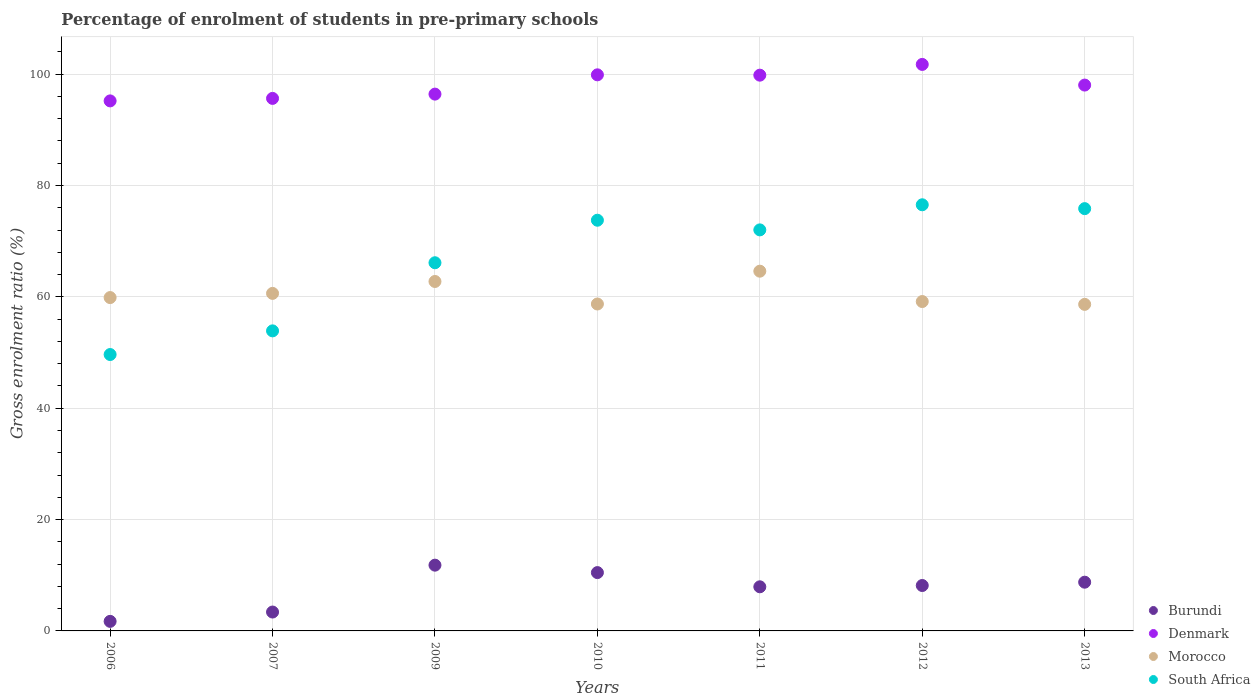Is the number of dotlines equal to the number of legend labels?
Your response must be concise. Yes. What is the percentage of students enrolled in pre-primary schools in Denmark in 2012?
Your answer should be compact. 101.75. Across all years, what is the maximum percentage of students enrolled in pre-primary schools in South Africa?
Make the answer very short. 76.54. Across all years, what is the minimum percentage of students enrolled in pre-primary schools in Morocco?
Provide a short and direct response. 58.66. In which year was the percentage of students enrolled in pre-primary schools in Burundi maximum?
Your answer should be compact. 2009. What is the total percentage of students enrolled in pre-primary schools in South Africa in the graph?
Offer a terse response. 467.86. What is the difference between the percentage of students enrolled in pre-primary schools in Burundi in 2006 and that in 2009?
Offer a terse response. -10.1. What is the difference between the percentage of students enrolled in pre-primary schools in Burundi in 2011 and the percentage of students enrolled in pre-primary schools in South Africa in 2010?
Your response must be concise. -65.84. What is the average percentage of students enrolled in pre-primary schools in South Africa per year?
Provide a short and direct response. 66.84. In the year 2006, what is the difference between the percentage of students enrolled in pre-primary schools in South Africa and percentage of students enrolled in pre-primary schools in Denmark?
Your answer should be very brief. -45.56. What is the ratio of the percentage of students enrolled in pre-primary schools in Denmark in 2007 to that in 2013?
Make the answer very short. 0.98. What is the difference between the highest and the second highest percentage of students enrolled in pre-primary schools in Denmark?
Provide a succinct answer. 1.87. What is the difference between the highest and the lowest percentage of students enrolled in pre-primary schools in South Africa?
Provide a short and direct response. 26.9. In how many years, is the percentage of students enrolled in pre-primary schools in Morocco greater than the average percentage of students enrolled in pre-primary schools in Morocco taken over all years?
Offer a terse response. 2. Is it the case that in every year, the sum of the percentage of students enrolled in pre-primary schools in Denmark and percentage of students enrolled in pre-primary schools in Burundi  is greater than the sum of percentage of students enrolled in pre-primary schools in Morocco and percentage of students enrolled in pre-primary schools in South Africa?
Keep it short and to the point. No. Is it the case that in every year, the sum of the percentage of students enrolled in pre-primary schools in Burundi and percentage of students enrolled in pre-primary schools in Denmark  is greater than the percentage of students enrolled in pre-primary schools in Morocco?
Provide a short and direct response. Yes. Does the percentage of students enrolled in pre-primary schools in Morocco monotonically increase over the years?
Your answer should be compact. No. How many dotlines are there?
Ensure brevity in your answer.  4. What is the difference between two consecutive major ticks on the Y-axis?
Give a very brief answer. 20. Does the graph contain any zero values?
Give a very brief answer. No. How many legend labels are there?
Offer a very short reply. 4. What is the title of the graph?
Give a very brief answer. Percentage of enrolment of students in pre-primary schools. Does "Guam" appear as one of the legend labels in the graph?
Offer a very short reply. No. What is the label or title of the X-axis?
Your response must be concise. Years. What is the Gross enrolment ratio (%) of Burundi in 2006?
Ensure brevity in your answer.  1.72. What is the Gross enrolment ratio (%) in Denmark in 2006?
Make the answer very short. 95.2. What is the Gross enrolment ratio (%) in Morocco in 2006?
Your response must be concise. 59.88. What is the Gross enrolment ratio (%) of South Africa in 2006?
Make the answer very short. 49.65. What is the Gross enrolment ratio (%) in Burundi in 2007?
Ensure brevity in your answer.  3.39. What is the Gross enrolment ratio (%) in Denmark in 2007?
Your answer should be very brief. 95.65. What is the Gross enrolment ratio (%) in Morocco in 2007?
Provide a succinct answer. 60.63. What is the Gross enrolment ratio (%) in South Africa in 2007?
Your answer should be compact. 53.89. What is the Gross enrolment ratio (%) of Burundi in 2009?
Ensure brevity in your answer.  11.81. What is the Gross enrolment ratio (%) in Denmark in 2009?
Your response must be concise. 96.42. What is the Gross enrolment ratio (%) of Morocco in 2009?
Provide a succinct answer. 62.77. What is the Gross enrolment ratio (%) of South Africa in 2009?
Offer a terse response. 66.13. What is the Gross enrolment ratio (%) of Burundi in 2010?
Provide a succinct answer. 10.48. What is the Gross enrolment ratio (%) of Denmark in 2010?
Give a very brief answer. 99.88. What is the Gross enrolment ratio (%) of Morocco in 2010?
Offer a very short reply. 58.72. What is the Gross enrolment ratio (%) in South Africa in 2010?
Provide a short and direct response. 73.77. What is the Gross enrolment ratio (%) of Burundi in 2011?
Provide a short and direct response. 7.93. What is the Gross enrolment ratio (%) of Denmark in 2011?
Keep it short and to the point. 99.82. What is the Gross enrolment ratio (%) in Morocco in 2011?
Give a very brief answer. 64.61. What is the Gross enrolment ratio (%) in South Africa in 2011?
Provide a short and direct response. 72.03. What is the Gross enrolment ratio (%) of Burundi in 2012?
Keep it short and to the point. 8.16. What is the Gross enrolment ratio (%) of Denmark in 2012?
Your answer should be very brief. 101.75. What is the Gross enrolment ratio (%) in Morocco in 2012?
Make the answer very short. 59.16. What is the Gross enrolment ratio (%) in South Africa in 2012?
Provide a short and direct response. 76.54. What is the Gross enrolment ratio (%) of Burundi in 2013?
Offer a terse response. 8.75. What is the Gross enrolment ratio (%) in Denmark in 2013?
Offer a terse response. 98.04. What is the Gross enrolment ratio (%) in Morocco in 2013?
Your response must be concise. 58.66. What is the Gross enrolment ratio (%) in South Africa in 2013?
Ensure brevity in your answer.  75.85. Across all years, what is the maximum Gross enrolment ratio (%) in Burundi?
Make the answer very short. 11.81. Across all years, what is the maximum Gross enrolment ratio (%) of Denmark?
Keep it short and to the point. 101.75. Across all years, what is the maximum Gross enrolment ratio (%) of Morocco?
Provide a succinct answer. 64.61. Across all years, what is the maximum Gross enrolment ratio (%) in South Africa?
Make the answer very short. 76.54. Across all years, what is the minimum Gross enrolment ratio (%) in Burundi?
Your response must be concise. 1.72. Across all years, what is the minimum Gross enrolment ratio (%) of Denmark?
Offer a very short reply. 95.2. Across all years, what is the minimum Gross enrolment ratio (%) in Morocco?
Offer a terse response. 58.66. Across all years, what is the minimum Gross enrolment ratio (%) of South Africa?
Keep it short and to the point. 49.65. What is the total Gross enrolment ratio (%) in Burundi in the graph?
Keep it short and to the point. 52.23. What is the total Gross enrolment ratio (%) of Denmark in the graph?
Offer a terse response. 686.78. What is the total Gross enrolment ratio (%) in Morocco in the graph?
Provide a short and direct response. 424.42. What is the total Gross enrolment ratio (%) of South Africa in the graph?
Keep it short and to the point. 467.86. What is the difference between the Gross enrolment ratio (%) in Burundi in 2006 and that in 2007?
Offer a terse response. -1.68. What is the difference between the Gross enrolment ratio (%) of Denmark in 2006 and that in 2007?
Provide a succinct answer. -0.45. What is the difference between the Gross enrolment ratio (%) of Morocco in 2006 and that in 2007?
Make the answer very short. -0.75. What is the difference between the Gross enrolment ratio (%) of South Africa in 2006 and that in 2007?
Provide a succinct answer. -4.25. What is the difference between the Gross enrolment ratio (%) in Burundi in 2006 and that in 2009?
Offer a very short reply. -10.1. What is the difference between the Gross enrolment ratio (%) in Denmark in 2006 and that in 2009?
Make the answer very short. -1.22. What is the difference between the Gross enrolment ratio (%) in Morocco in 2006 and that in 2009?
Your response must be concise. -2.89. What is the difference between the Gross enrolment ratio (%) of South Africa in 2006 and that in 2009?
Your response must be concise. -16.49. What is the difference between the Gross enrolment ratio (%) of Burundi in 2006 and that in 2010?
Provide a short and direct response. -8.76. What is the difference between the Gross enrolment ratio (%) in Denmark in 2006 and that in 2010?
Make the answer very short. -4.68. What is the difference between the Gross enrolment ratio (%) in Morocco in 2006 and that in 2010?
Keep it short and to the point. 1.15. What is the difference between the Gross enrolment ratio (%) of South Africa in 2006 and that in 2010?
Make the answer very short. -24.12. What is the difference between the Gross enrolment ratio (%) in Burundi in 2006 and that in 2011?
Ensure brevity in your answer.  -6.21. What is the difference between the Gross enrolment ratio (%) of Denmark in 2006 and that in 2011?
Your answer should be very brief. -4.62. What is the difference between the Gross enrolment ratio (%) of Morocco in 2006 and that in 2011?
Offer a very short reply. -4.74. What is the difference between the Gross enrolment ratio (%) in South Africa in 2006 and that in 2011?
Provide a short and direct response. -22.39. What is the difference between the Gross enrolment ratio (%) in Burundi in 2006 and that in 2012?
Your answer should be very brief. -6.44. What is the difference between the Gross enrolment ratio (%) of Denmark in 2006 and that in 2012?
Your response must be concise. -6.55. What is the difference between the Gross enrolment ratio (%) in Morocco in 2006 and that in 2012?
Ensure brevity in your answer.  0.71. What is the difference between the Gross enrolment ratio (%) in South Africa in 2006 and that in 2012?
Your answer should be compact. -26.9. What is the difference between the Gross enrolment ratio (%) in Burundi in 2006 and that in 2013?
Make the answer very short. -7.04. What is the difference between the Gross enrolment ratio (%) of Denmark in 2006 and that in 2013?
Make the answer very short. -2.84. What is the difference between the Gross enrolment ratio (%) of Morocco in 2006 and that in 2013?
Offer a terse response. 1.22. What is the difference between the Gross enrolment ratio (%) of South Africa in 2006 and that in 2013?
Provide a succinct answer. -26.2. What is the difference between the Gross enrolment ratio (%) in Burundi in 2007 and that in 2009?
Your answer should be very brief. -8.42. What is the difference between the Gross enrolment ratio (%) in Denmark in 2007 and that in 2009?
Provide a short and direct response. -0.77. What is the difference between the Gross enrolment ratio (%) of Morocco in 2007 and that in 2009?
Your response must be concise. -2.14. What is the difference between the Gross enrolment ratio (%) of South Africa in 2007 and that in 2009?
Give a very brief answer. -12.24. What is the difference between the Gross enrolment ratio (%) of Burundi in 2007 and that in 2010?
Your answer should be compact. -7.08. What is the difference between the Gross enrolment ratio (%) in Denmark in 2007 and that in 2010?
Your response must be concise. -4.23. What is the difference between the Gross enrolment ratio (%) in Morocco in 2007 and that in 2010?
Ensure brevity in your answer.  1.91. What is the difference between the Gross enrolment ratio (%) of South Africa in 2007 and that in 2010?
Keep it short and to the point. -19.87. What is the difference between the Gross enrolment ratio (%) of Burundi in 2007 and that in 2011?
Your answer should be very brief. -4.53. What is the difference between the Gross enrolment ratio (%) in Denmark in 2007 and that in 2011?
Provide a succinct answer. -4.17. What is the difference between the Gross enrolment ratio (%) of Morocco in 2007 and that in 2011?
Provide a succinct answer. -3.99. What is the difference between the Gross enrolment ratio (%) in South Africa in 2007 and that in 2011?
Your answer should be very brief. -18.14. What is the difference between the Gross enrolment ratio (%) in Burundi in 2007 and that in 2012?
Make the answer very short. -4.77. What is the difference between the Gross enrolment ratio (%) of Denmark in 2007 and that in 2012?
Your answer should be very brief. -6.1. What is the difference between the Gross enrolment ratio (%) of Morocco in 2007 and that in 2012?
Your response must be concise. 1.46. What is the difference between the Gross enrolment ratio (%) of South Africa in 2007 and that in 2012?
Your answer should be very brief. -22.65. What is the difference between the Gross enrolment ratio (%) in Burundi in 2007 and that in 2013?
Your answer should be compact. -5.36. What is the difference between the Gross enrolment ratio (%) in Denmark in 2007 and that in 2013?
Your response must be concise. -2.39. What is the difference between the Gross enrolment ratio (%) of Morocco in 2007 and that in 2013?
Give a very brief answer. 1.97. What is the difference between the Gross enrolment ratio (%) of South Africa in 2007 and that in 2013?
Ensure brevity in your answer.  -21.96. What is the difference between the Gross enrolment ratio (%) in Burundi in 2009 and that in 2010?
Give a very brief answer. 1.34. What is the difference between the Gross enrolment ratio (%) of Denmark in 2009 and that in 2010?
Make the answer very short. -3.47. What is the difference between the Gross enrolment ratio (%) of Morocco in 2009 and that in 2010?
Your answer should be very brief. 4.04. What is the difference between the Gross enrolment ratio (%) of South Africa in 2009 and that in 2010?
Your answer should be compact. -7.64. What is the difference between the Gross enrolment ratio (%) of Burundi in 2009 and that in 2011?
Keep it short and to the point. 3.89. What is the difference between the Gross enrolment ratio (%) in Denmark in 2009 and that in 2011?
Give a very brief answer. -3.4. What is the difference between the Gross enrolment ratio (%) in Morocco in 2009 and that in 2011?
Offer a very short reply. -1.85. What is the difference between the Gross enrolment ratio (%) in South Africa in 2009 and that in 2011?
Make the answer very short. -5.9. What is the difference between the Gross enrolment ratio (%) of Burundi in 2009 and that in 2012?
Provide a short and direct response. 3.65. What is the difference between the Gross enrolment ratio (%) in Denmark in 2009 and that in 2012?
Your response must be concise. -5.33. What is the difference between the Gross enrolment ratio (%) of Morocco in 2009 and that in 2012?
Your answer should be compact. 3.6. What is the difference between the Gross enrolment ratio (%) of South Africa in 2009 and that in 2012?
Ensure brevity in your answer.  -10.41. What is the difference between the Gross enrolment ratio (%) in Burundi in 2009 and that in 2013?
Provide a succinct answer. 3.06. What is the difference between the Gross enrolment ratio (%) in Denmark in 2009 and that in 2013?
Your answer should be very brief. -1.63. What is the difference between the Gross enrolment ratio (%) of Morocco in 2009 and that in 2013?
Make the answer very short. 4.11. What is the difference between the Gross enrolment ratio (%) of South Africa in 2009 and that in 2013?
Offer a terse response. -9.72. What is the difference between the Gross enrolment ratio (%) in Burundi in 2010 and that in 2011?
Your answer should be compact. 2.55. What is the difference between the Gross enrolment ratio (%) in Denmark in 2010 and that in 2011?
Your answer should be compact. 0.06. What is the difference between the Gross enrolment ratio (%) of Morocco in 2010 and that in 2011?
Provide a short and direct response. -5.89. What is the difference between the Gross enrolment ratio (%) in South Africa in 2010 and that in 2011?
Provide a short and direct response. 1.73. What is the difference between the Gross enrolment ratio (%) of Burundi in 2010 and that in 2012?
Your response must be concise. 2.32. What is the difference between the Gross enrolment ratio (%) of Denmark in 2010 and that in 2012?
Your answer should be very brief. -1.87. What is the difference between the Gross enrolment ratio (%) in Morocco in 2010 and that in 2012?
Your answer should be very brief. -0.44. What is the difference between the Gross enrolment ratio (%) in South Africa in 2010 and that in 2012?
Your response must be concise. -2.78. What is the difference between the Gross enrolment ratio (%) in Burundi in 2010 and that in 2013?
Provide a short and direct response. 1.72. What is the difference between the Gross enrolment ratio (%) in Denmark in 2010 and that in 2013?
Provide a succinct answer. 1.84. What is the difference between the Gross enrolment ratio (%) of Morocco in 2010 and that in 2013?
Offer a terse response. 0.07. What is the difference between the Gross enrolment ratio (%) of South Africa in 2010 and that in 2013?
Keep it short and to the point. -2.08. What is the difference between the Gross enrolment ratio (%) in Burundi in 2011 and that in 2012?
Give a very brief answer. -0.23. What is the difference between the Gross enrolment ratio (%) in Denmark in 2011 and that in 2012?
Ensure brevity in your answer.  -1.93. What is the difference between the Gross enrolment ratio (%) in Morocco in 2011 and that in 2012?
Make the answer very short. 5.45. What is the difference between the Gross enrolment ratio (%) in South Africa in 2011 and that in 2012?
Offer a very short reply. -4.51. What is the difference between the Gross enrolment ratio (%) of Burundi in 2011 and that in 2013?
Your answer should be very brief. -0.83. What is the difference between the Gross enrolment ratio (%) of Denmark in 2011 and that in 2013?
Make the answer very short. 1.78. What is the difference between the Gross enrolment ratio (%) of Morocco in 2011 and that in 2013?
Offer a terse response. 5.96. What is the difference between the Gross enrolment ratio (%) in South Africa in 2011 and that in 2013?
Offer a very short reply. -3.82. What is the difference between the Gross enrolment ratio (%) in Burundi in 2012 and that in 2013?
Provide a succinct answer. -0.6. What is the difference between the Gross enrolment ratio (%) of Denmark in 2012 and that in 2013?
Provide a short and direct response. 3.71. What is the difference between the Gross enrolment ratio (%) of Morocco in 2012 and that in 2013?
Ensure brevity in your answer.  0.51. What is the difference between the Gross enrolment ratio (%) in South Africa in 2012 and that in 2013?
Your response must be concise. 0.69. What is the difference between the Gross enrolment ratio (%) in Burundi in 2006 and the Gross enrolment ratio (%) in Denmark in 2007?
Ensure brevity in your answer.  -93.94. What is the difference between the Gross enrolment ratio (%) in Burundi in 2006 and the Gross enrolment ratio (%) in Morocco in 2007?
Offer a terse response. -58.91. What is the difference between the Gross enrolment ratio (%) of Burundi in 2006 and the Gross enrolment ratio (%) of South Africa in 2007?
Give a very brief answer. -52.18. What is the difference between the Gross enrolment ratio (%) of Denmark in 2006 and the Gross enrolment ratio (%) of Morocco in 2007?
Provide a short and direct response. 34.58. What is the difference between the Gross enrolment ratio (%) in Denmark in 2006 and the Gross enrolment ratio (%) in South Africa in 2007?
Offer a very short reply. 41.31. What is the difference between the Gross enrolment ratio (%) of Morocco in 2006 and the Gross enrolment ratio (%) of South Africa in 2007?
Provide a short and direct response. 5.98. What is the difference between the Gross enrolment ratio (%) in Burundi in 2006 and the Gross enrolment ratio (%) in Denmark in 2009?
Your answer should be compact. -94.7. What is the difference between the Gross enrolment ratio (%) of Burundi in 2006 and the Gross enrolment ratio (%) of Morocco in 2009?
Ensure brevity in your answer.  -61.05. What is the difference between the Gross enrolment ratio (%) in Burundi in 2006 and the Gross enrolment ratio (%) in South Africa in 2009?
Offer a terse response. -64.41. What is the difference between the Gross enrolment ratio (%) of Denmark in 2006 and the Gross enrolment ratio (%) of Morocco in 2009?
Provide a short and direct response. 32.44. What is the difference between the Gross enrolment ratio (%) of Denmark in 2006 and the Gross enrolment ratio (%) of South Africa in 2009?
Offer a terse response. 29.07. What is the difference between the Gross enrolment ratio (%) of Morocco in 2006 and the Gross enrolment ratio (%) of South Africa in 2009?
Provide a short and direct response. -6.26. What is the difference between the Gross enrolment ratio (%) in Burundi in 2006 and the Gross enrolment ratio (%) in Denmark in 2010?
Keep it short and to the point. -98.17. What is the difference between the Gross enrolment ratio (%) in Burundi in 2006 and the Gross enrolment ratio (%) in Morocco in 2010?
Give a very brief answer. -57.01. What is the difference between the Gross enrolment ratio (%) of Burundi in 2006 and the Gross enrolment ratio (%) of South Africa in 2010?
Make the answer very short. -72.05. What is the difference between the Gross enrolment ratio (%) of Denmark in 2006 and the Gross enrolment ratio (%) of Morocco in 2010?
Offer a very short reply. 36.48. What is the difference between the Gross enrolment ratio (%) of Denmark in 2006 and the Gross enrolment ratio (%) of South Africa in 2010?
Your answer should be compact. 21.44. What is the difference between the Gross enrolment ratio (%) in Morocco in 2006 and the Gross enrolment ratio (%) in South Africa in 2010?
Your answer should be compact. -13.89. What is the difference between the Gross enrolment ratio (%) of Burundi in 2006 and the Gross enrolment ratio (%) of Denmark in 2011?
Provide a succinct answer. -98.11. What is the difference between the Gross enrolment ratio (%) of Burundi in 2006 and the Gross enrolment ratio (%) of Morocco in 2011?
Keep it short and to the point. -62.9. What is the difference between the Gross enrolment ratio (%) of Burundi in 2006 and the Gross enrolment ratio (%) of South Africa in 2011?
Ensure brevity in your answer.  -70.32. What is the difference between the Gross enrolment ratio (%) of Denmark in 2006 and the Gross enrolment ratio (%) of Morocco in 2011?
Offer a terse response. 30.59. What is the difference between the Gross enrolment ratio (%) of Denmark in 2006 and the Gross enrolment ratio (%) of South Africa in 2011?
Offer a very short reply. 23.17. What is the difference between the Gross enrolment ratio (%) of Morocco in 2006 and the Gross enrolment ratio (%) of South Africa in 2011?
Give a very brief answer. -12.16. What is the difference between the Gross enrolment ratio (%) in Burundi in 2006 and the Gross enrolment ratio (%) in Denmark in 2012?
Ensure brevity in your answer.  -100.04. What is the difference between the Gross enrolment ratio (%) of Burundi in 2006 and the Gross enrolment ratio (%) of Morocco in 2012?
Give a very brief answer. -57.45. What is the difference between the Gross enrolment ratio (%) of Burundi in 2006 and the Gross enrolment ratio (%) of South Africa in 2012?
Give a very brief answer. -74.83. What is the difference between the Gross enrolment ratio (%) of Denmark in 2006 and the Gross enrolment ratio (%) of Morocco in 2012?
Make the answer very short. 36.04. What is the difference between the Gross enrolment ratio (%) of Denmark in 2006 and the Gross enrolment ratio (%) of South Africa in 2012?
Offer a terse response. 18.66. What is the difference between the Gross enrolment ratio (%) in Morocco in 2006 and the Gross enrolment ratio (%) in South Africa in 2012?
Your response must be concise. -16.67. What is the difference between the Gross enrolment ratio (%) in Burundi in 2006 and the Gross enrolment ratio (%) in Denmark in 2013?
Make the answer very short. -96.33. What is the difference between the Gross enrolment ratio (%) in Burundi in 2006 and the Gross enrolment ratio (%) in Morocco in 2013?
Offer a very short reply. -56.94. What is the difference between the Gross enrolment ratio (%) in Burundi in 2006 and the Gross enrolment ratio (%) in South Africa in 2013?
Provide a short and direct response. -74.13. What is the difference between the Gross enrolment ratio (%) of Denmark in 2006 and the Gross enrolment ratio (%) of Morocco in 2013?
Keep it short and to the point. 36.55. What is the difference between the Gross enrolment ratio (%) in Denmark in 2006 and the Gross enrolment ratio (%) in South Africa in 2013?
Give a very brief answer. 19.35. What is the difference between the Gross enrolment ratio (%) in Morocco in 2006 and the Gross enrolment ratio (%) in South Africa in 2013?
Your response must be concise. -15.97. What is the difference between the Gross enrolment ratio (%) in Burundi in 2007 and the Gross enrolment ratio (%) in Denmark in 2009?
Your answer should be very brief. -93.03. What is the difference between the Gross enrolment ratio (%) of Burundi in 2007 and the Gross enrolment ratio (%) of Morocco in 2009?
Your answer should be very brief. -59.37. What is the difference between the Gross enrolment ratio (%) of Burundi in 2007 and the Gross enrolment ratio (%) of South Africa in 2009?
Provide a succinct answer. -62.74. What is the difference between the Gross enrolment ratio (%) in Denmark in 2007 and the Gross enrolment ratio (%) in Morocco in 2009?
Offer a terse response. 32.89. What is the difference between the Gross enrolment ratio (%) in Denmark in 2007 and the Gross enrolment ratio (%) in South Africa in 2009?
Offer a terse response. 29.52. What is the difference between the Gross enrolment ratio (%) of Morocco in 2007 and the Gross enrolment ratio (%) of South Africa in 2009?
Make the answer very short. -5.5. What is the difference between the Gross enrolment ratio (%) of Burundi in 2007 and the Gross enrolment ratio (%) of Denmark in 2010?
Provide a short and direct response. -96.49. What is the difference between the Gross enrolment ratio (%) of Burundi in 2007 and the Gross enrolment ratio (%) of Morocco in 2010?
Offer a terse response. -55.33. What is the difference between the Gross enrolment ratio (%) of Burundi in 2007 and the Gross enrolment ratio (%) of South Africa in 2010?
Make the answer very short. -70.38. What is the difference between the Gross enrolment ratio (%) of Denmark in 2007 and the Gross enrolment ratio (%) of Morocco in 2010?
Your answer should be very brief. 36.93. What is the difference between the Gross enrolment ratio (%) of Denmark in 2007 and the Gross enrolment ratio (%) of South Africa in 2010?
Give a very brief answer. 21.88. What is the difference between the Gross enrolment ratio (%) of Morocco in 2007 and the Gross enrolment ratio (%) of South Africa in 2010?
Offer a terse response. -13.14. What is the difference between the Gross enrolment ratio (%) in Burundi in 2007 and the Gross enrolment ratio (%) in Denmark in 2011?
Provide a short and direct response. -96.43. What is the difference between the Gross enrolment ratio (%) of Burundi in 2007 and the Gross enrolment ratio (%) of Morocco in 2011?
Offer a very short reply. -61.22. What is the difference between the Gross enrolment ratio (%) of Burundi in 2007 and the Gross enrolment ratio (%) of South Africa in 2011?
Your answer should be very brief. -68.64. What is the difference between the Gross enrolment ratio (%) in Denmark in 2007 and the Gross enrolment ratio (%) in Morocco in 2011?
Your response must be concise. 31.04. What is the difference between the Gross enrolment ratio (%) in Denmark in 2007 and the Gross enrolment ratio (%) in South Africa in 2011?
Provide a short and direct response. 23.62. What is the difference between the Gross enrolment ratio (%) of Morocco in 2007 and the Gross enrolment ratio (%) of South Africa in 2011?
Offer a very short reply. -11.41. What is the difference between the Gross enrolment ratio (%) of Burundi in 2007 and the Gross enrolment ratio (%) of Denmark in 2012?
Your response must be concise. -98.36. What is the difference between the Gross enrolment ratio (%) in Burundi in 2007 and the Gross enrolment ratio (%) in Morocco in 2012?
Ensure brevity in your answer.  -55.77. What is the difference between the Gross enrolment ratio (%) in Burundi in 2007 and the Gross enrolment ratio (%) in South Africa in 2012?
Keep it short and to the point. -73.15. What is the difference between the Gross enrolment ratio (%) in Denmark in 2007 and the Gross enrolment ratio (%) in Morocco in 2012?
Your answer should be compact. 36.49. What is the difference between the Gross enrolment ratio (%) in Denmark in 2007 and the Gross enrolment ratio (%) in South Africa in 2012?
Your answer should be compact. 19.11. What is the difference between the Gross enrolment ratio (%) of Morocco in 2007 and the Gross enrolment ratio (%) of South Africa in 2012?
Make the answer very short. -15.92. What is the difference between the Gross enrolment ratio (%) of Burundi in 2007 and the Gross enrolment ratio (%) of Denmark in 2013?
Your answer should be compact. -94.65. What is the difference between the Gross enrolment ratio (%) of Burundi in 2007 and the Gross enrolment ratio (%) of Morocco in 2013?
Make the answer very short. -55.26. What is the difference between the Gross enrolment ratio (%) in Burundi in 2007 and the Gross enrolment ratio (%) in South Africa in 2013?
Give a very brief answer. -72.46. What is the difference between the Gross enrolment ratio (%) in Denmark in 2007 and the Gross enrolment ratio (%) in Morocco in 2013?
Make the answer very short. 37. What is the difference between the Gross enrolment ratio (%) of Denmark in 2007 and the Gross enrolment ratio (%) of South Africa in 2013?
Ensure brevity in your answer.  19.8. What is the difference between the Gross enrolment ratio (%) in Morocco in 2007 and the Gross enrolment ratio (%) in South Africa in 2013?
Ensure brevity in your answer.  -15.22. What is the difference between the Gross enrolment ratio (%) of Burundi in 2009 and the Gross enrolment ratio (%) of Denmark in 2010?
Your answer should be compact. -88.07. What is the difference between the Gross enrolment ratio (%) of Burundi in 2009 and the Gross enrolment ratio (%) of Morocco in 2010?
Your answer should be compact. -46.91. What is the difference between the Gross enrolment ratio (%) in Burundi in 2009 and the Gross enrolment ratio (%) in South Africa in 2010?
Ensure brevity in your answer.  -61.96. What is the difference between the Gross enrolment ratio (%) in Denmark in 2009 and the Gross enrolment ratio (%) in Morocco in 2010?
Your response must be concise. 37.7. What is the difference between the Gross enrolment ratio (%) of Denmark in 2009 and the Gross enrolment ratio (%) of South Africa in 2010?
Provide a short and direct response. 22.65. What is the difference between the Gross enrolment ratio (%) of Morocco in 2009 and the Gross enrolment ratio (%) of South Africa in 2010?
Ensure brevity in your answer.  -11. What is the difference between the Gross enrolment ratio (%) of Burundi in 2009 and the Gross enrolment ratio (%) of Denmark in 2011?
Your response must be concise. -88.01. What is the difference between the Gross enrolment ratio (%) of Burundi in 2009 and the Gross enrolment ratio (%) of Morocco in 2011?
Provide a short and direct response. -52.8. What is the difference between the Gross enrolment ratio (%) in Burundi in 2009 and the Gross enrolment ratio (%) in South Africa in 2011?
Your answer should be compact. -60.22. What is the difference between the Gross enrolment ratio (%) in Denmark in 2009 and the Gross enrolment ratio (%) in Morocco in 2011?
Your answer should be very brief. 31.8. What is the difference between the Gross enrolment ratio (%) of Denmark in 2009 and the Gross enrolment ratio (%) of South Africa in 2011?
Provide a short and direct response. 24.39. What is the difference between the Gross enrolment ratio (%) of Morocco in 2009 and the Gross enrolment ratio (%) of South Africa in 2011?
Provide a short and direct response. -9.27. What is the difference between the Gross enrolment ratio (%) of Burundi in 2009 and the Gross enrolment ratio (%) of Denmark in 2012?
Offer a very short reply. -89.94. What is the difference between the Gross enrolment ratio (%) in Burundi in 2009 and the Gross enrolment ratio (%) in Morocco in 2012?
Ensure brevity in your answer.  -47.35. What is the difference between the Gross enrolment ratio (%) of Burundi in 2009 and the Gross enrolment ratio (%) of South Africa in 2012?
Provide a short and direct response. -64.73. What is the difference between the Gross enrolment ratio (%) of Denmark in 2009 and the Gross enrolment ratio (%) of Morocco in 2012?
Ensure brevity in your answer.  37.26. What is the difference between the Gross enrolment ratio (%) of Denmark in 2009 and the Gross enrolment ratio (%) of South Africa in 2012?
Make the answer very short. 19.88. What is the difference between the Gross enrolment ratio (%) in Morocco in 2009 and the Gross enrolment ratio (%) in South Africa in 2012?
Offer a terse response. -13.78. What is the difference between the Gross enrolment ratio (%) of Burundi in 2009 and the Gross enrolment ratio (%) of Denmark in 2013?
Offer a terse response. -86.23. What is the difference between the Gross enrolment ratio (%) in Burundi in 2009 and the Gross enrolment ratio (%) in Morocco in 2013?
Provide a succinct answer. -46.84. What is the difference between the Gross enrolment ratio (%) in Burundi in 2009 and the Gross enrolment ratio (%) in South Africa in 2013?
Keep it short and to the point. -64.04. What is the difference between the Gross enrolment ratio (%) in Denmark in 2009 and the Gross enrolment ratio (%) in Morocco in 2013?
Provide a short and direct response. 37.76. What is the difference between the Gross enrolment ratio (%) of Denmark in 2009 and the Gross enrolment ratio (%) of South Africa in 2013?
Offer a very short reply. 20.57. What is the difference between the Gross enrolment ratio (%) of Morocco in 2009 and the Gross enrolment ratio (%) of South Africa in 2013?
Keep it short and to the point. -13.08. What is the difference between the Gross enrolment ratio (%) of Burundi in 2010 and the Gross enrolment ratio (%) of Denmark in 2011?
Your answer should be compact. -89.35. What is the difference between the Gross enrolment ratio (%) in Burundi in 2010 and the Gross enrolment ratio (%) in Morocco in 2011?
Make the answer very short. -54.14. What is the difference between the Gross enrolment ratio (%) of Burundi in 2010 and the Gross enrolment ratio (%) of South Africa in 2011?
Provide a short and direct response. -61.56. What is the difference between the Gross enrolment ratio (%) of Denmark in 2010 and the Gross enrolment ratio (%) of Morocco in 2011?
Your answer should be very brief. 35.27. What is the difference between the Gross enrolment ratio (%) in Denmark in 2010 and the Gross enrolment ratio (%) in South Africa in 2011?
Your answer should be compact. 27.85. What is the difference between the Gross enrolment ratio (%) of Morocco in 2010 and the Gross enrolment ratio (%) of South Africa in 2011?
Your answer should be very brief. -13.31. What is the difference between the Gross enrolment ratio (%) in Burundi in 2010 and the Gross enrolment ratio (%) in Denmark in 2012?
Your response must be concise. -91.28. What is the difference between the Gross enrolment ratio (%) of Burundi in 2010 and the Gross enrolment ratio (%) of Morocco in 2012?
Provide a succinct answer. -48.69. What is the difference between the Gross enrolment ratio (%) in Burundi in 2010 and the Gross enrolment ratio (%) in South Africa in 2012?
Provide a succinct answer. -66.07. What is the difference between the Gross enrolment ratio (%) of Denmark in 2010 and the Gross enrolment ratio (%) of Morocco in 2012?
Give a very brief answer. 40.72. What is the difference between the Gross enrolment ratio (%) of Denmark in 2010 and the Gross enrolment ratio (%) of South Africa in 2012?
Ensure brevity in your answer.  23.34. What is the difference between the Gross enrolment ratio (%) of Morocco in 2010 and the Gross enrolment ratio (%) of South Africa in 2012?
Provide a short and direct response. -17.82. What is the difference between the Gross enrolment ratio (%) of Burundi in 2010 and the Gross enrolment ratio (%) of Denmark in 2013?
Offer a terse response. -87.57. What is the difference between the Gross enrolment ratio (%) in Burundi in 2010 and the Gross enrolment ratio (%) in Morocco in 2013?
Provide a short and direct response. -48.18. What is the difference between the Gross enrolment ratio (%) in Burundi in 2010 and the Gross enrolment ratio (%) in South Africa in 2013?
Make the answer very short. -65.37. What is the difference between the Gross enrolment ratio (%) of Denmark in 2010 and the Gross enrolment ratio (%) of Morocco in 2013?
Your response must be concise. 41.23. What is the difference between the Gross enrolment ratio (%) in Denmark in 2010 and the Gross enrolment ratio (%) in South Africa in 2013?
Make the answer very short. 24.03. What is the difference between the Gross enrolment ratio (%) of Morocco in 2010 and the Gross enrolment ratio (%) of South Africa in 2013?
Your answer should be compact. -17.13. What is the difference between the Gross enrolment ratio (%) of Burundi in 2011 and the Gross enrolment ratio (%) of Denmark in 2012?
Give a very brief answer. -93.83. What is the difference between the Gross enrolment ratio (%) in Burundi in 2011 and the Gross enrolment ratio (%) in Morocco in 2012?
Provide a short and direct response. -51.24. What is the difference between the Gross enrolment ratio (%) in Burundi in 2011 and the Gross enrolment ratio (%) in South Africa in 2012?
Provide a succinct answer. -68.62. What is the difference between the Gross enrolment ratio (%) of Denmark in 2011 and the Gross enrolment ratio (%) of Morocco in 2012?
Provide a succinct answer. 40.66. What is the difference between the Gross enrolment ratio (%) in Denmark in 2011 and the Gross enrolment ratio (%) in South Africa in 2012?
Make the answer very short. 23.28. What is the difference between the Gross enrolment ratio (%) of Morocco in 2011 and the Gross enrolment ratio (%) of South Africa in 2012?
Your answer should be very brief. -11.93. What is the difference between the Gross enrolment ratio (%) in Burundi in 2011 and the Gross enrolment ratio (%) in Denmark in 2013?
Offer a very short reply. -90.12. What is the difference between the Gross enrolment ratio (%) of Burundi in 2011 and the Gross enrolment ratio (%) of Morocco in 2013?
Keep it short and to the point. -50.73. What is the difference between the Gross enrolment ratio (%) of Burundi in 2011 and the Gross enrolment ratio (%) of South Africa in 2013?
Keep it short and to the point. -67.92. What is the difference between the Gross enrolment ratio (%) of Denmark in 2011 and the Gross enrolment ratio (%) of Morocco in 2013?
Your response must be concise. 41.17. What is the difference between the Gross enrolment ratio (%) in Denmark in 2011 and the Gross enrolment ratio (%) in South Africa in 2013?
Give a very brief answer. 23.97. What is the difference between the Gross enrolment ratio (%) in Morocco in 2011 and the Gross enrolment ratio (%) in South Africa in 2013?
Your answer should be compact. -11.24. What is the difference between the Gross enrolment ratio (%) of Burundi in 2012 and the Gross enrolment ratio (%) of Denmark in 2013?
Offer a terse response. -89.89. What is the difference between the Gross enrolment ratio (%) of Burundi in 2012 and the Gross enrolment ratio (%) of Morocco in 2013?
Make the answer very short. -50.5. What is the difference between the Gross enrolment ratio (%) of Burundi in 2012 and the Gross enrolment ratio (%) of South Africa in 2013?
Offer a very short reply. -67.69. What is the difference between the Gross enrolment ratio (%) of Denmark in 2012 and the Gross enrolment ratio (%) of Morocco in 2013?
Ensure brevity in your answer.  43.1. What is the difference between the Gross enrolment ratio (%) of Denmark in 2012 and the Gross enrolment ratio (%) of South Africa in 2013?
Your answer should be very brief. 25.9. What is the difference between the Gross enrolment ratio (%) of Morocco in 2012 and the Gross enrolment ratio (%) of South Africa in 2013?
Keep it short and to the point. -16.69. What is the average Gross enrolment ratio (%) of Burundi per year?
Your answer should be very brief. 7.46. What is the average Gross enrolment ratio (%) in Denmark per year?
Your response must be concise. 98.11. What is the average Gross enrolment ratio (%) of Morocco per year?
Make the answer very short. 60.63. What is the average Gross enrolment ratio (%) in South Africa per year?
Your answer should be compact. 66.84. In the year 2006, what is the difference between the Gross enrolment ratio (%) in Burundi and Gross enrolment ratio (%) in Denmark?
Keep it short and to the point. -93.49. In the year 2006, what is the difference between the Gross enrolment ratio (%) of Burundi and Gross enrolment ratio (%) of Morocco?
Offer a very short reply. -58.16. In the year 2006, what is the difference between the Gross enrolment ratio (%) in Burundi and Gross enrolment ratio (%) in South Africa?
Provide a succinct answer. -47.93. In the year 2006, what is the difference between the Gross enrolment ratio (%) in Denmark and Gross enrolment ratio (%) in Morocco?
Keep it short and to the point. 35.33. In the year 2006, what is the difference between the Gross enrolment ratio (%) in Denmark and Gross enrolment ratio (%) in South Africa?
Give a very brief answer. 45.56. In the year 2006, what is the difference between the Gross enrolment ratio (%) in Morocco and Gross enrolment ratio (%) in South Africa?
Keep it short and to the point. 10.23. In the year 2007, what is the difference between the Gross enrolment ratio (%) in Burundi and Gross enrolment ratio (%) in Denmark?
Provide a succinct answer. -92.26. In the year 2007, what is the difference between the Gross enrolment ratio (%) in Burundi and Gross enrolment ratio (%) in Morocco?
Provide a succinct answer. -57.23. In the year 2007, what is the difference between the Gross enrolment ratio (%) in Burundi and Gross enrolment ratio (%) in South Africa?
Offer a terse response. -50.5. In the year 2007, what is the difference between the Gross enrolment ratio (%) of Denmark and Gross enrolment ratio (%) of Morocco?
Your answer should be very brief. 35.03. In the year 2007, what is the difference between the Gross enrolment ratio (%) of Denmark and Gross enrolment ratio (%) of South Africa?
Offer a terse response. 41.76. In the year 2007, what is the difference between the Gross enrolment ratio (%) of Morocco and Gross enrolment ratio (%) of South Africa?
Provide a short and direct response. 6.73. In the year 2009, what is the difference between the Gross enrolment ratio (%) in Burundi and Gross enrolment ratio (%) in Denmark?
Offer a terse response. -84.61. In the year 2009, what is the difference between the Gross enrolment ratio (%) in Burundi and Gross enrolment ratio (%) in Morocco?
Keep it short and to the point. -50.95. In the year 2009, what is the difference between the Gross enrolment ratio (%) of Burundi and Gross enrolment ratio (%) of South Africa?
Give a very brief answer. -54.32. In the year 2009, what is the difference between the Gross enrolment ratio (%) of Denmark and Gross enrolment ratio (%) of Morocco?
Make the answer very short. 33.65. In the year 2009, what is the difference between the Gross enrolment ratio (%) in Denmark and Gross enrolment ratio (%) in South Africa?
Give a very brief answer. 30.29. In the year 2009, what is the difference between the Gross enrolment ratio (%) in Morocco and Gross enrolment ratio (%) in South Africa?
Make the answer very short. -3.36. In the year 2010, what is the difference between the Gross enrolment ratio (%) of Burundi and Gross enrolment ratio (%) of Denmark?
Your answer should be very brief. -89.41. In the year 2010, what is the difference between the Gross enrolment ratio (%) of Burundi and Gross enrolment ratio (%) of Morocco?
Provide a short and direct response. -48.24. In the year 2010, what is the difference between the Gross enrolment ratio (%) of Burundi and Gross enrolment ratio (%) of South Africa?
Provide a short and direct response. -63.29. In the year 2010, what is the difference between the Gross enrolment ratio (%) of Denmark and Gross enrolment ratio (%) of Morocco?
Offer a very short reply. 41.16. In the year 2010, what is the difference between the Gross enrolment ratio (%) in Denmark and Gross enrolment ratio (%) in South Africa?
Provide a short and direct response. 26.12. In the year 2010, what is the difference between the Gross enrolment ratio (%) of Morocco and Gross enrolment ratio (%) of South Africa?
Keep it short and to the point. -15.05. In the year 2011, what is the difference between the Gross enrolment ratio (%) in Burundi and Gross enrolment ratio (%) in Denmark?
Offer a terse response. -91.9. In the year 2011, what is the difference between the Gross enrolment ratio (%) in Burundi and Gross enrolment ratio (%) in Morocco?
Ensure brevity in your answer.  -56.69. In the year 2011, what is the difference between the Gross enrolment ratio (%) of Burundi and Gross enrolment ratio (%) of South Africa?
Make the answer very short. -64.11. In the year 2011, what is the difference between the Gross enrolment ratio (%) of Denmark and Gross enrolment ratio (%) of Morocco?
Keep it short and to the point. 35.21. In the year 2011, what is the difference between the Gross enrolment ratio (%) in Denmark and Gross enrolment ratio (%) in South Africa?
Provide a succinct answer. 27.79. In the year 2011, what is the difference between the Gross enrolment ratio (%) of Morocco and Gross enrolment ratio (%) of South Africa?
Your answer should be very brief. -7.42. In the year 2012, what is the difference between the Gross enrolment ratio (%) in Burundi and Gross enrolment ratio (%) in Denmark?
Make the answer very short. -93.6. In the year 2012, what is the difference between the Gross enrolment ratio (%) in Burundi and Gross enrolment ratio (%) in Morocco?
Your answer should be very brief. -51.01. In the year 2012, what is the difference between the Gross enrolment ratio (%) in Burundi and Gross enrolment ratio (%) in South Africa?
Make the answer very short. -68.39. In the year 2012, what is the difference between the Gross enrolment ratio (%) of Denmark and Gross enrolment ratio (%) of Morocco?
Your response must be concise. 42.59. In the year 2012, what is the difference between the Gross enrolment ratio (%) of Denmark and Gross enrolment ratio (%) of South Africa?
Provide a short and direct response. 25.21. In the year 2012, what is the difference between the Gross enrolment ratio (%) in Morocco and Gross enrolment ratio (%) in South Africa?
Ensure brevity in your answer.  -17.38. In the year 2013, what is the difference between the Gross enrolment ratio (%) in Burundi and Gross enrolment ratio (%) in Denmark?
Keep it short and to the point. -89.29. In the year 2013, what is the difference between the Gross enrolment ratio (%) of Burundi and Gross enrolment ratio (%) of Morocco?
Your answer should be compact. -49.9. In the year 2013, what is the difference between the Gross enrolment ratio (%) in Burundi and Gross enrolment ratio (%) in South Africa?
Keep it short and to the point. -67.1. In the year 2013, what is the difference between the Gross enrolment ratio (%) of Denmark and Gross enrolment ratio (%) of Morocco?
Your answer should be very brief. 39.39. In the year 2013, what is the difference between the Gross enrolment ratio (%) of Denmark and Gross enrolment ratio (%) of South Africa?
Your answer should be very brief. 22.19. In the year 2013, what is the difference between the Gross enrolment ratio (%) of Morocco and Gross enrolment ratio (%) of South Africa?
Make the answer very short. -17.19. What is the ratio of the Gross enrolment ratio (%) of Burundi in 2006 to that in 2007?
Your response must be concise. 0.51. What is the ratio of the Gross enrolment ratio (%) of Denmark in 2006 to that in 2007?
Offer a terse response. 1. What is the ratio of the Gross enrolment ratio (%) of Morocco in 2006 to that in 2007?
Ensure brevity in your answer.  0.99. What is the ratio of the Gross enrolment ratio (%) of South Africa in 2006 to that in 2007?
Your response must be concise. 0.92. What is the ratio of the Gross enrolment ratio (%) of Burundi in 2006 to that in 2009?
Provide a short and direct response. 0.15. What is the ratio of the Gross enrolment ratio (%) in Denmark in 2006 to that in 2009?
Make the answer very short. 0.99. What is the ratio of the Gross enrolment ratio (%) of Morocco in 2006 to that in 2009?
Provide a short and direct response. 0.95. What is the ratio of the Gross enrolment ratio (%) of South Africa in 2006 to that in 2009?
Give a very brief answer. 0.75. What is the ratio of the Gross enrolment ratio (%) in Burundi in 2006 to that in 2010?
Make the answer very short. 0.16. What is the ratio of the Gross enrolment ratio (%) in Denmark in 2006 to that in 2010?
Your response must be concise. 0.95. What is the ratio of the Gross enrolment ratio (%) in Morocco in 2006 to that in 2010?
Your answer should be compact. 1.02. What is the ratio of the Gross enrolment ratio (%) in South Africa in 2006 to that in 2010?
Your answer should be very brief. 0.67. What is the ratio of the Gross enrolment ratio (%) in Burundi in 2006 to that in 2011?
Make the answer very short. 0.22. What is the ratio of the Gross enrolment ratio (%) of Denmark in 2006 to that in 2011?
Offer a very short reply. 0.95. What is the ratio of the Gross enrolment ratio (%) in Morocco in 2006 to that in 2011?
Your response must be concise. 0.93. What is the ratio of the Gross enrolment ratio (%) of South Africa in 2006 to that in 2011?
Ensure brevity in your answer.  0.69. What is the ratio of the Gross enrolment ratio (%) of Burundi in 2006 to that in 2012?
Give a very brief answer. 0.21. What is the ratio of the Gross enrolment ratio (%) in Denmark in 2006 to that in 2012?
Your answer should be very brief. 0.94. What is the ratio of the Gross enrolment ratio (%) in Morocco in 2006 to that in 2012?
Your answer should be very brief. 1.01. What is the ratio of the Gross enrolment ratio (%) of South Africa in 2006 to that in 2012?
Provide a succinct answer. 0.65. What is the ratio of the Gross enrolment ratio (%) of Burundi in 2006 to that in 2013?
Your response must be concise. 0.2. What is the ratio of the Gross enrolment ratio (%) of Morocco in 2006 to that in 2013?
Your answer should be compact. 1.02. What is the ratio of the Gross enrolment ratio (%) of South Africa in 2006 to that in 2013?
Offer a terse response. 0.65. What is the ratio of the Gross enrolment ratio (%) in Burundi in 2007 to that in 2009?
Your response must be concise. 0.29. What is the ratio of the Gross enrolment ratio (%) in Morocco in 2007 to that in 2009?
Offer a terse response. 0.97. What is the ratio of the Gross enrolment ratio (%) of South Africa in 2007 to that in 2009?
Offer a terse response. 0.81. What is the ratio of the Gross enrolment ratio (%) in Burundi in 2007 to that in 2010?
Your answer should be compact. 0.32. What is the ratio of the Gross enrolment ratio (%) in Denmark in 2007 to that in 2010?
Offer a terse response. 0.96. What is the ratio of the Gross enrolment ratio (%) in Morocco in 2007 to that in 2010?
Give a very brief answer. 1.03. What is the ratio of the Gross enrolment ratio (%) of South Africa in 2007 to that in 2010?
Keep it short and to the point. 0.73. What is the ratio of the Gross enrolment ratio (%) in Burundi in 2007 to that in 2011?
Keep it short and to the point. 0.43. What is the ratio of the Gross enrolment ratio (%) in Denmark in 2007 to that in 2011?
Offer a terse response. 0.96. What is the ratio of the Gross enrolment ratio (%) of Morocco in 2007 to that in 2011?
Give a very brief answer. 0.94. What is the ratio of the Gross enrolment ratio (%) of South Africa in 2007 to that in 2011?
Make the answer very short. 0.75. What is the ratio of the Gross enrolment ratio (%) in Burundi in 2007 to that in 2012?
Your answer should be compact. 0.42. What is the ratio of the Gross enrolment ratio (%) of Denmark in 2007 to that in 2012?
Your answer should be compact. 0.94. What is the ratio of the Gross enrolment ratio (%) in Morocco in 2007 to that in 2012?
Keep it short and to the point. 1.02. What is the ratio of the Gross enrolment ratio (%) of South Africa in 2007 to that in 2012?
Provide a short and direct response. 0.7. What is the ratio of the Gross enrolment ratio (%) of Burundi in 2007 to that in 2013?
Give a very brief answer. 0.39. What is the ratio of the Gross enrolment ratio (%) in Denmark in 2007 to that in 2013?
Keep it short and to the point. 0.98. What is the ratio of the Gross enrolment ratio (%) of Morocco in 2007 to that in 2013?
Keep it short and to the point. 1.03. What is the ratio of the Gross enrolment ratio (%) in South Africa in 2007 to that in 2013?
Make the answer very short. 0.71. What is the ratio of the Gross enrolment ratio (%) in Burundi in 2009 to that in 2010?
Make the answer very short. 1.13. What is the ratio of the Gross enrolment ratio (%) in Denmark in 2009 to that in 2010?
Your answer should be compact. 0.97. What is the ratio of the Gross enrolment ratio (%) in Morocco in 2009 to that in 2010?
Provide a succinct answer. 1.07. What is the ratio of the Gross enrolment ratio (%) of South Africa in 2009 to that in 2010?
Ensure brevity in your answer.  0.9. What is the ratio of the Gross enrolment ratio (%) in Burundi in 2009 to that in 2011?
Ensure brevity in your answer.  1.49. What is the ratio of the Gross enrolment ratio (%) of Denmark in 2009 to that in 2011?
Make the answer very short. 0.97. What is the ratio of the Gross enrolment ratio (%) of Morocco in 2009 to that in 2011?
Make the answer very short. 0.97. What is the ratio of the Gross enrolment ratio (%) of South Africa in 2009 to that in 2011?
Give a very brief answer. 0.92. What is the ratio of the Gross enrolment ratio (%) of Burundi in 2009 to that in 2012?
Keep it short and to the point. 1.45. What is the ratio of the Gross enrolment ratio (%) of Denmark in 2009 to that in 2012?
Keep it short and to the point. 0.95. What is the ratio of the Gross enrolment ratio (%) of Morocco in 2009 to that in 2012?
Ensure brevity in your answer.  1.06. What is the ratio of the Gross enrolment ratio (%) in South Africa in 2009 to that in 2012?
Your response must be concise. 0.86. What is the ratio of the Gross enrolment ratio (%) of Burundi in 2009 to that in 2013?
Provide a succinct answer. 1.35. What is the ratio of the Gross enrolment ratio (%) of Denmark in 2009 to that in 2013?
Your answer should be compact. 0.98. What is the ratio of the Gross enrolment ratio (%) in Morocco in 2009 to that in 2013?
Your response must be concise. 1.07. What is the ratio of the Gross enrolment ratio (%) in South Africa in 2009 to that in 2013?
Your answer should be very brief. 0.87. What is the ratio of the Gross enrolment ratio (%) in Burundi in 2010 to that in 2011?
Give a very brief answer. 1.32. What is the ratio of the Gross enrolment ratio (%) of Denmark in 2010 to that in 2011?
Your answer should be compact. 1. What is the ratio of the Gross enrolment ratio (%) of Morocco in 2010 to that in 2011?
Make the answer very short. 0.91. What is the ratio of the Gross enrolment ratio (%) of South Africa in 2010 to that in 2011?
Provide a succinct answer. 1.02. What is the ratio of the Gross enrolment ratio (%) of Burundi in 2010 to that in 2012?
Your response must be concise. 1.28. What is the ratio of the Gross enrolment ratio (%) in Denmark in 2010 to that in 2012?
Your response must be concise. 0.98. What is the ratio of the Gross enrolment ratio (%) of Morocco in 2010 to that in 2012?
Make the answer very short. 0.99. What is the ratio of the Gross enrolment ratio (%) in South Africa in 2010 to that in 2012?
Your answer should be very brief. 0.96. What is the ratio of the Gross enrolment ratio (%) of Burundi in 2010 to that in 2013?
Give a very brief answer. 1.2. What is the ratio of the Gross enrolment ratio (%) of Denmark in 2010 to that in 2013?
Provide a succinct answer. 1.02. What is the ratio of the Gross enrolment ratio (%) in Morocco in 2010 to that in 2013?
Your response must be concise. 1. What is the ratio of the Gross enrolment ratio (%) in South Africa in 2010 to that in 2013?
Make the answer very short. 0.97. What is the ratio of the Gross enrolment ratio (%) of Burundi in 2011 to that in 2012?
Offer a very short reply. 0.97. What is the ratio of the Gross enrolment ratio (%) of Morocco in 2011 to that in 2012?
Provide a succinct answer. 1.09. What is the ratio of the Gross enrolment ratio (%) in South Africa in 2011 to that in 2012?
Keep it short and to the point. 0.94. What is the ratio of the Gross enrolment ratio (%) in Burundi in 2011 to that in 2013?
Your answer should be very brief. 0.91. What is the ratio of the Gross enrolment ratio (%) in Denmark in 2011 to that in 2013?
Your answer should be very brief. 1.02. What is the ratio of the Gross enrolment ratio (%) of Morocco in 2011 to that in 2013?
Provide a succinct answer. 1.1. What is the ratio of the Gross enrolment ratio (%) of South Africa in 2011 to that in 2013?
Make the answer very short. 0.95. What is the ratio of the Gross enrolment ratio (%) of Burundi in 2012 to that in 2013?
Your response must be concise. 0.93. What is the ratio of the Gross enrolment ratio (%) of Denmark in 2012 to that in 2013?
Your answer should be compact. 1.04. What is the ratio of the Gross enrolment ratio (%) in Morocco in 2012 to that in 2013?
Your answer should be compact. 1.01. What is the ratio of the Gross enrolment ratio (%) in South Africa in 2012 to that in 2013?
Provide a succinct answer. 1.01. What is the difference between the highest and the second highest Gross enrolment ratio (%) of Burundi?
Provide a short and direct response. 1.34. What is the difference between the highest and the second highest Gross enrolment ratio (%) of Denmark?
Your response must be concise. 1.87. What is the difference between the highest and the second highest Gross enrolment ratio (%) of Morocco?
Offer a terse response. 1.85. What is the difference between the highest and the second highest Gross enrolment ratio (%) of South Africa?
Ensure brevity in your answer.  0.69. What is the difference between the highest and the lowest Gross enrolment ratio (%) of Burundi?
Make the answer very short. 10.1. What is the difference between the highest and the lowest Gross enrolment ratio (%) of Denmark?
Provide a succinct answer. 6.55. What is the difference between the highest and the lowest Gross enrolment ratio (%) in Morocco?
Offer a very short reply. 5.96. What is the difference between the highest and the lowest Gross enrolment ratio (%) of South Africa?
Provide a short and direct response. 26.9. 